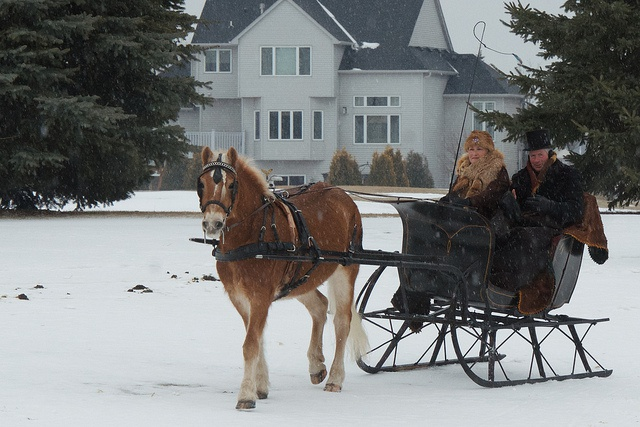Describe the objects in this image and their specific colors. I can see horse in black, maroon, brown, and darkgray tones, people in black, gray, maroon, and brown tones, and people in black, brown, and gray tones in this image. 